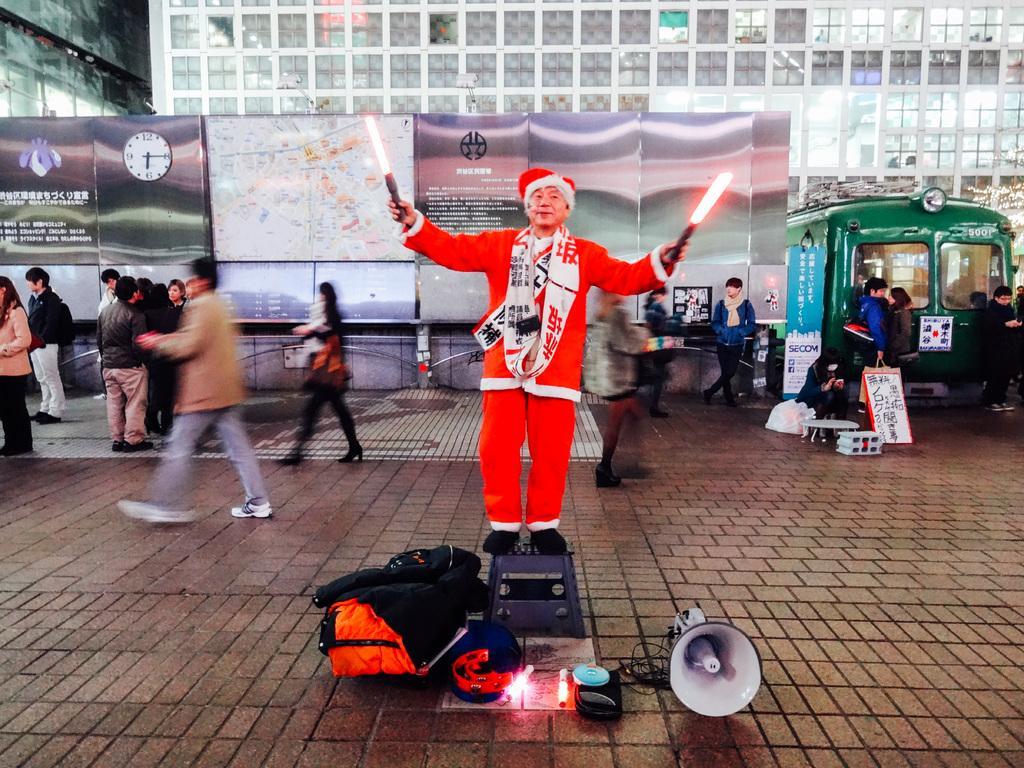Describe this image in one or two sentences. In this image I can see a man is standing in the front and I can see he is holding two stick lights. I can see he is wearing red colour dress, red colour cap and black shoes. In the front of him I can see few more stick lights, a mega phone, a bag and few other things. In the background I can see number of people are standing. I can also see few boards and on these words I can see something is written. On the right side of this image I can see a green colour tram. 